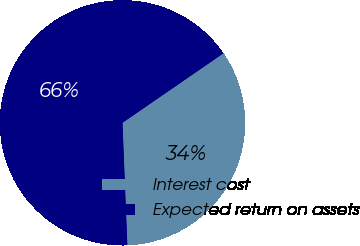Convert chart to OTSL. <chart><loc_0><loc_0><loc_500><loc_500><pie_chart><fcel>Interest cost<fcel>Expected return on assets<nl><fcel>33.96%<fcel>66.04%<nl></chart> 